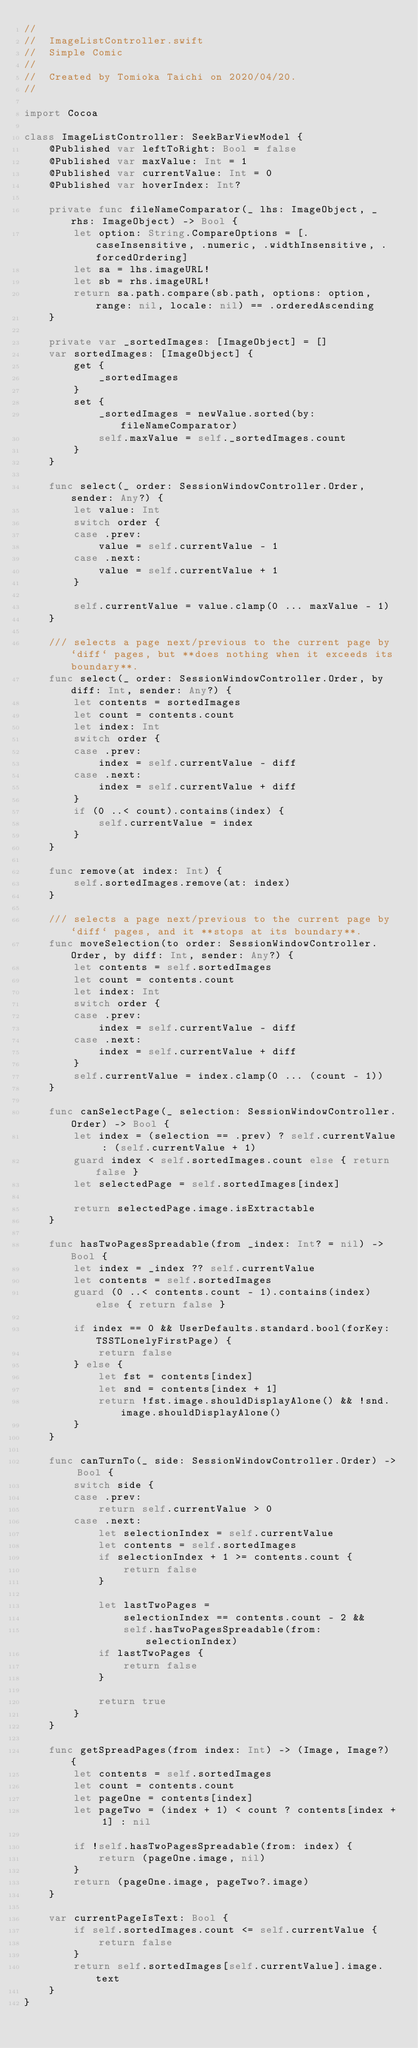Convert code to text. <code><loc_0><loc_0><loc_500><loc_500><_Swift_>//
//  ImageListController.swift
//  Simple Comic
//
//  Created by Tomioka Taichi on 2020/04/20.
//

import Cocoa

class ImageListController: SeekBarViewModel {
    @Published var leftToRight: Bool = false
    @Published var maxValue: Int = 1
    @Published var currentValue: Int = 0
    @Published var hoverIndex: Int?
    
    private func fileNameComparator(_ lhs: ImageObject, _ rhs: ImageObject) -> Bool {
        let option: String.CompareOptions = [.caseInsensitive, .numeric, .widthInsensitive, .forcedOrdering]
        let sa = lhs.imageURL!
        let sb = rhs.imageURL!
        return sa.path.compare(sb.path, options: option, range: nil, locale: nil) == .orderedAscending
    }
    
    private var _sortedImages: [ImageObject] = []
    var sortedImages: [ImageObject] {
        get {
            _sortedImages
        }
        set {
            _sortedImages = newValue.sorted(by: fileNameComparator)
            self.maxValue = self._sortedImages.count
        }
    }
    
    func select(_ order: SessionWindowController.Order, sender: Any?) {
        let value: Int
        switch order {
        case .prev:
            value = self.currentValue - 1
        case .next:
            value = self.currentValue + 1
        }
        
        self.currentValue = value.clamp(0 ... maxValue - 1)
    }

    /// selects a page next/previous to the current page by `diff` pages, but **does nothing when it exceeds its boundary**.
    func select(_ order: SessionWindowController.Order, by diff: Int, sender: Any?) {
        let contents = sortedImages
        let count = contents.count
        let index: Int
        switch order {
        case .prev:
            index = self.currentValue - diff
        case .next:
            index = self.currentValue + diff
        }
        if (0 ..< count).contains(index) {
            self.currentValue = index
        }
    }
    
    func remove(at index: Int) {
        self.sortedImages.remove(at: index)
    }

    /// selects a page next/previous to the current page by `diff` pages, and it **stops at its boundary**.
    func moveSelection(to order: SessionWindowController.Order, by diff: Int, sender: Any?) {
        let contents = self.sortedImages
        let count = contents.count
        let index: Int
        switch order {
        case .prev:
            index = self.currentValue - diff
        case .next:
            index = self.currentValue + diff
        }
        self.currentValue = index.clamp(0 ... (count - 1))
    }
    
    func canSelectPage(_ selection: SessionWindowController.Order) -> Bool {
        let index = (selection == .prev) ? self.currentValue : (self.currentValue + 1)
        guard index < self.sortedImages.count else { return false }
        let selectedPage = self.sortedImages[index]

        return selectedPage.image.isExtractable
    }
    
    func hasTwoPagesSpreadable(from _index: Int? = nil) -> Bool {
        let index = _index ?? self.currentValue
        let contents = self.sortedImages
        guard (0 ..< contents.count - 1).contains(index) else { return false }

        if index == 0 && UserDefaults.standard.bool(forKey: TSSTLonelyFirstPage) {
            return false
        } else {
            let fst = contents[index]
            let snd = contents[index + 1]
            return !fst.image.shouldDisplayAlone() && !snd.image.shouldDisplayAlone()
        }
    }
    
    func canTurnTo(_ side: SessionWindowController.Order) -> Bool {
        switch side {
        case .prev:
            return self.currentValue > 0
        case .next:
            let selectionIndex = self.currentValue
            let contents = self.sortedImages
            if selectionIndex + 1 >= contents.count {
                return false
            }

            let lastTwoPages =
                selectionIndex == contents.count - 2 &&
                self.hasTwoPagesSpreadable(from: selectionIndex)
            if lastTwoPages {
                return false
            }

            return true
        }
    }
    
    func getSpreadPages(from index: Int) -> (Image, Image?) {
        let contents = self.sortedImages
        let count = contents.count
        let pageOne = contents[index]
        let pageTwo = (index + 1) < count ? contents[index + 1] : nil

        if !self.hasTwoPagesSpreadable(from: index) {
            return (pageOne.image, nil)
        }
        return (pageOne.image, pageTwo?.image)
    }
    
    var currentPageIsText: Bool {
        if self.sortedImages.count <= self.currentValue {
            return false
        }
        return self.sortedImages[self.currentValue].image.text
    }
}

</code> 